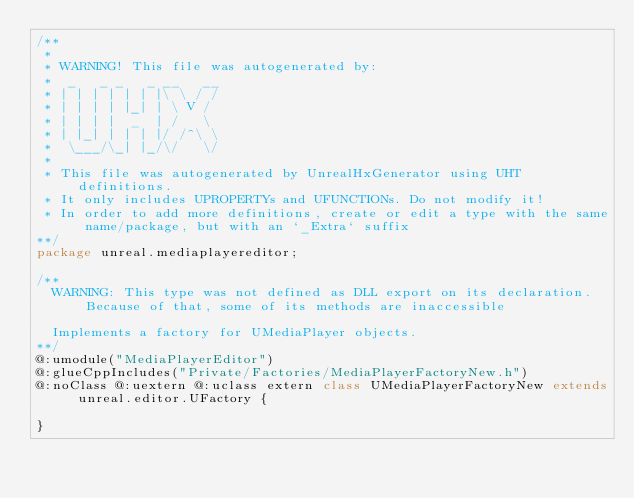Convert code to text. <code><loc_0><loc_0><loc_500><loc_500><_Haxe_>/**
 * 
 * WARNING! This file was autogenerated by: 
 *  _   _ _   _ __   __ 
 * | | | | | | |\ \ / / 
 * | | | | |_| | \ V /  
 * | | | |  _  | /   \  
 * | |_| | | | |/ /^\ \ 
 *  \___/\_| |_/\/   \/ 
 * 
 * This file was autogenerated by UnrealHxGenerator using UHT definitions.
 * It only includes UPROPERTYs and UFUNCTIONs. Do not modify it!
 * In order to add more definitions, create or edit a type with the same name/package, but with an `_Extra` suffix
**/
package unreal.mediaplayereditor;

/**
  WARNING: This type was not defined as DLL export on its declaration. Because of that, some of its methods are inaccessible
  
  Implements a factory for UMediaPlayer objects.
**/
@:umodule("MediaPlayerEditor")
@:glueCppIncludes("Private/Factories/MediaPlayerFactoryNew.h")
@:noClass @:uextern @:uclass extern class UMediaPlayerFactoryNew extends unreal.editor.UFactory {
  
}
</code> 